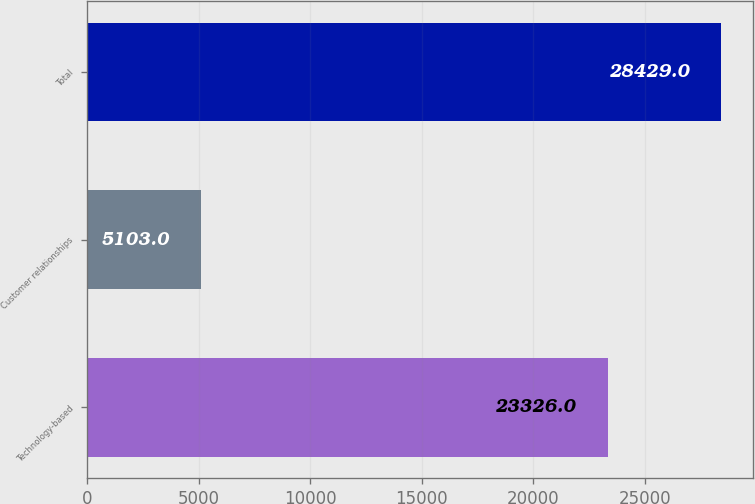Convert chart to OTSL. <chart><loc_0><loc_0><loc_500><loc_500><bar_chart><fcel>Technology-based<fcel>Customer relationships<fcel>Total<nl><fcel>23326<fcel>5103<fcel>28429<nl></chart> 